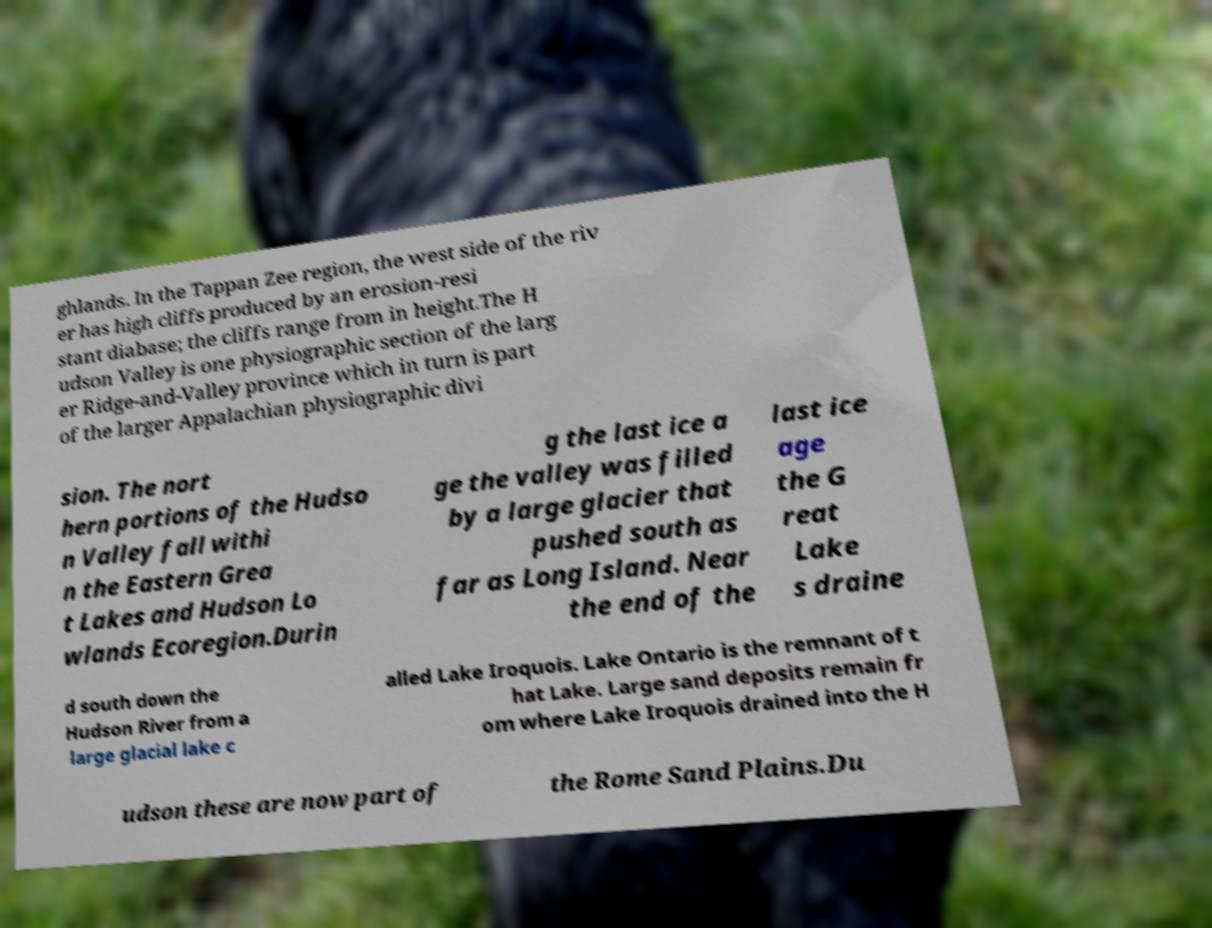Please read and relay the text visible in this image. What does it say? ghlands. In the Tappan Zee region, the west side of the riv er has high cliffs produced by an erosion-resi stant diabase; the cliffs range from in height.The H udson Valley is one physiographic section of the larg er Ridge-and-Valley province which in turn is part of the larger Appalachian physiographic divi sion. The nort hern portions of the Hudso n Valley fall withi n the Eastern Grea t Lakes and Hudson Lo wlands Ecoregion.Durin g the last ice a ge the valley was filled by a large glacier that pushed south as far as Long Island. Near the end of the last ice age the G reat Lake s draine d south down the Hudson River from a large glacial lake c alled Lake Iroquois. Lake Ontario is the remnant of t hat Lake. Large sand deposits remain fr om where Lake Iroquois drained into the H udson these are now part of the Rome Sand Plains.Du 